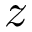Convert formula to latex. <formula><loc_0><loc_0><loc_500><loc_500>z</formula> 